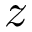Convert formula to latex. <formula><loc_0><loc_0><loc_500><loc_500>z</formula> 